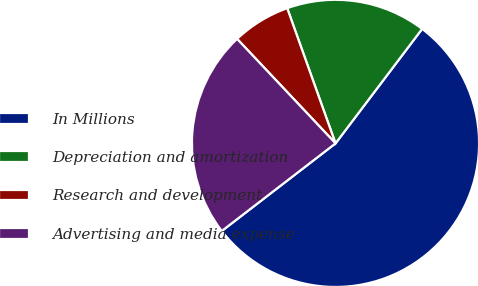Convert chart to OTSL. <chart><loc_0><loc_0><loc_500><loc_500><pie_chart><fcel>In Millions<fcel>Depreciation and amortization<fcel>Research and development<fcel>Advertising and media expense<nl><fcel>54.25%<fcel>15.77%<fcel>6.56%<fcel>23.42%<nl></chart> 